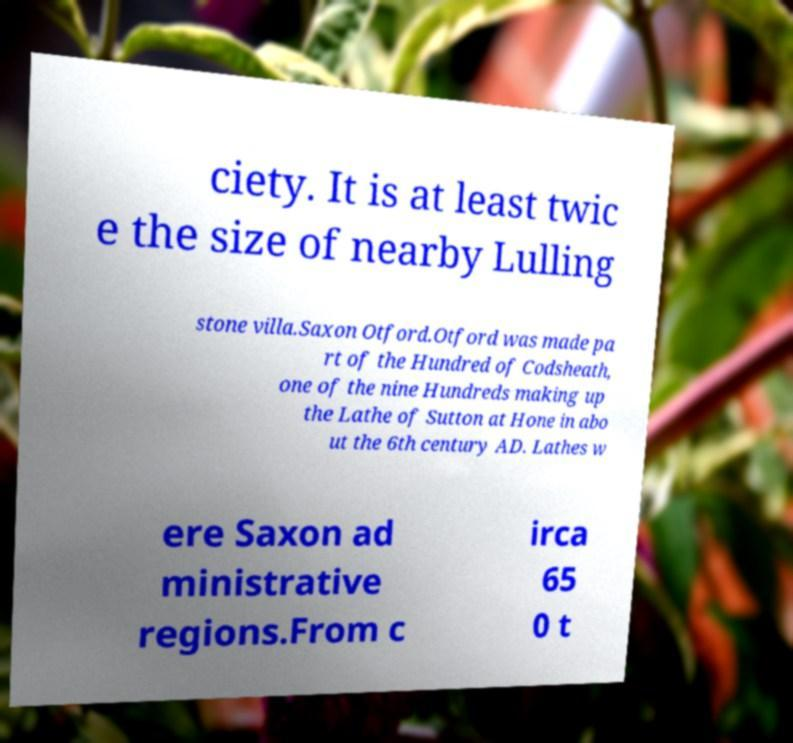Please read and relay the text visible in this image. What does it say? ciety. It is at least twic e the size of nearby Lulling stone villa.Saxon Otford.Otford was made pa rt of the Hundred of Codsheath, one of the nine Hundreds making up the Lathe of Sutton at Hone in abo ut the 6th century AD. Lathes w ere Saxon ad ministrative regions.From c irca 65 0 t 